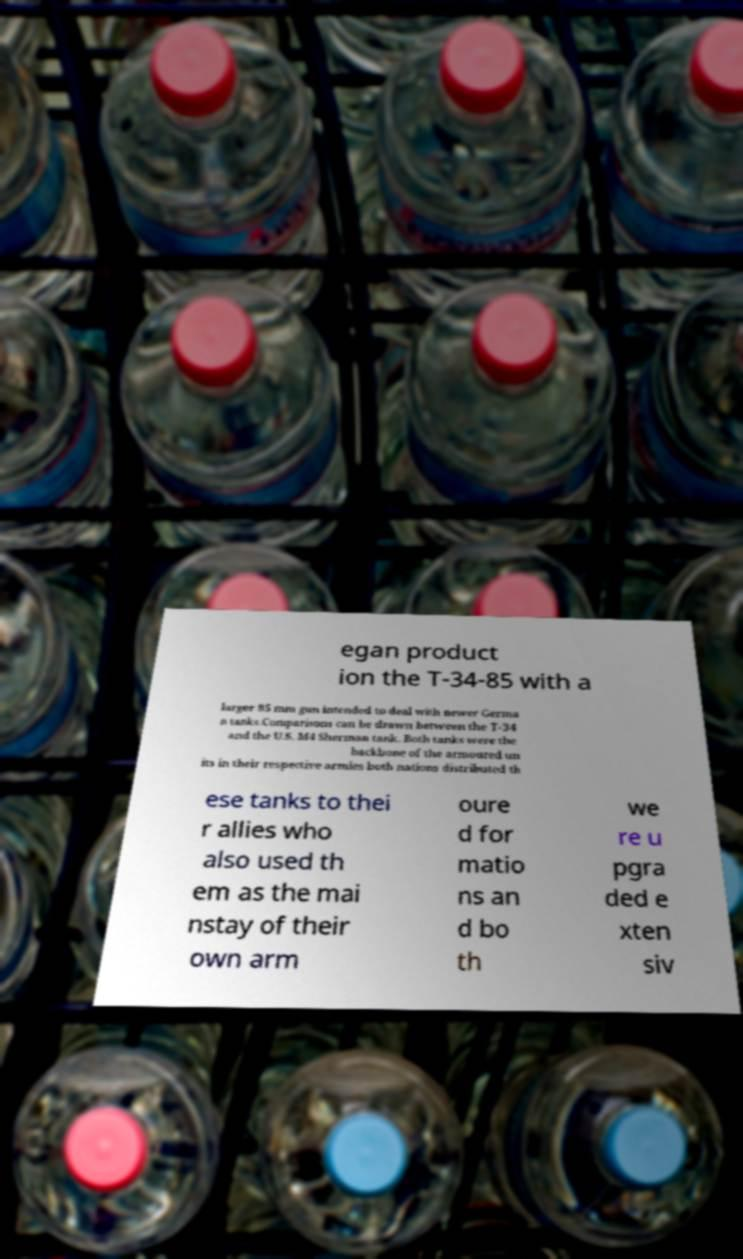For documentation purposes, I need the text within this image transcribed. Could you provide that? egan product ion the T-34-85 with a larger 85 mm gun intended to deal with newer Germa n tanks.Comparisons can be drawn between the T-34 and the U.S. M4 Sherman tank. Both tanks were the backbone of the armoured un its in their respective armies both nations distributed th ese tanks to thei r allies who also used th em as the mai nstay of their own arm oure d for matio ns an d bo th we re u pgra ded e xten siv 